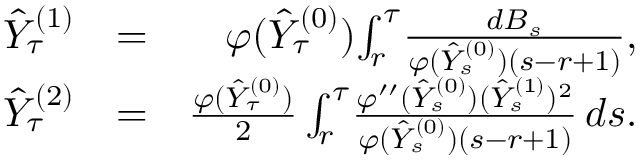<formula> <loc_0><loc_0><loc_500><loc_500>\begin{array} { r l r } { \hat { Y } _ { \tau } ^ { ( 1 ) } } & { = } & { \varphi ( \hat { Y } _ { \tau } ^ { ( 0 ) } ) \, \int _ { r } ^ { \tau } \, \frac { d B _ { s } } { \varphi ( \hat { Y } _ { s } ^ { ( 0 ) } ) ( s - r + 1 ) } , } \\ { \hat { Y } _ { \tau } ^ { ( 2 ) } } & { = } & { \frac { \varphi ( \hat { Y } _ { \tau } ^ { ( 0 ) } ) } { 2 } \int _ { r } ^ { \tau } \, \frac { \varphi ^ { \prime \prime } ( \hat { Y } _ { s } ^ { ( 0 ) } ) ( \hat { Y } _ { s } ^ { ( 1 ) } ) ^ { 2 } } { \varphi ( \hat { Y } _ { s } ^ { ( 0 ) } ) ( s - r + 1 ) } \, d s . } \end{array}</formula> 